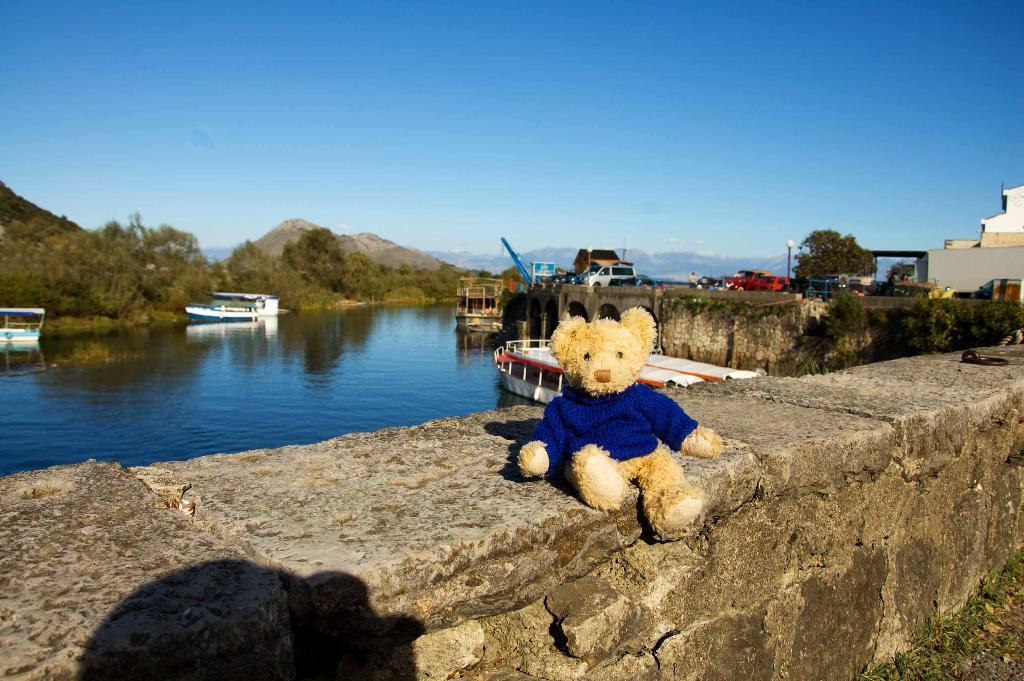Can you describe this image briefly? In the foreground of the picture I can see a teddy bear on the wall. I can see the ships in the water. There are vehicles on the road on the right side. I can see a house on the top right side. In the background, I can see the hills and trees. There are clouds in the sky. 